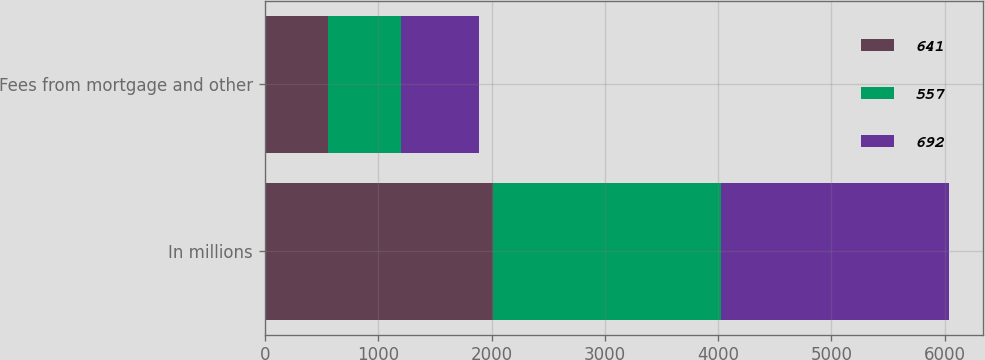Convert chart. <chart><loc_0><loc_0><loc_500><loc_500><stacked_bar_chart><ecel><fcel>In millions<fcel>Fees from mortgage and other<nl><fcel>641<fcel>2012<fcel>557<nl><fcel>557<fcel>2011<fcel>641<nl><fcel>692<fcel>2010<fcel>692<nl></chart> 